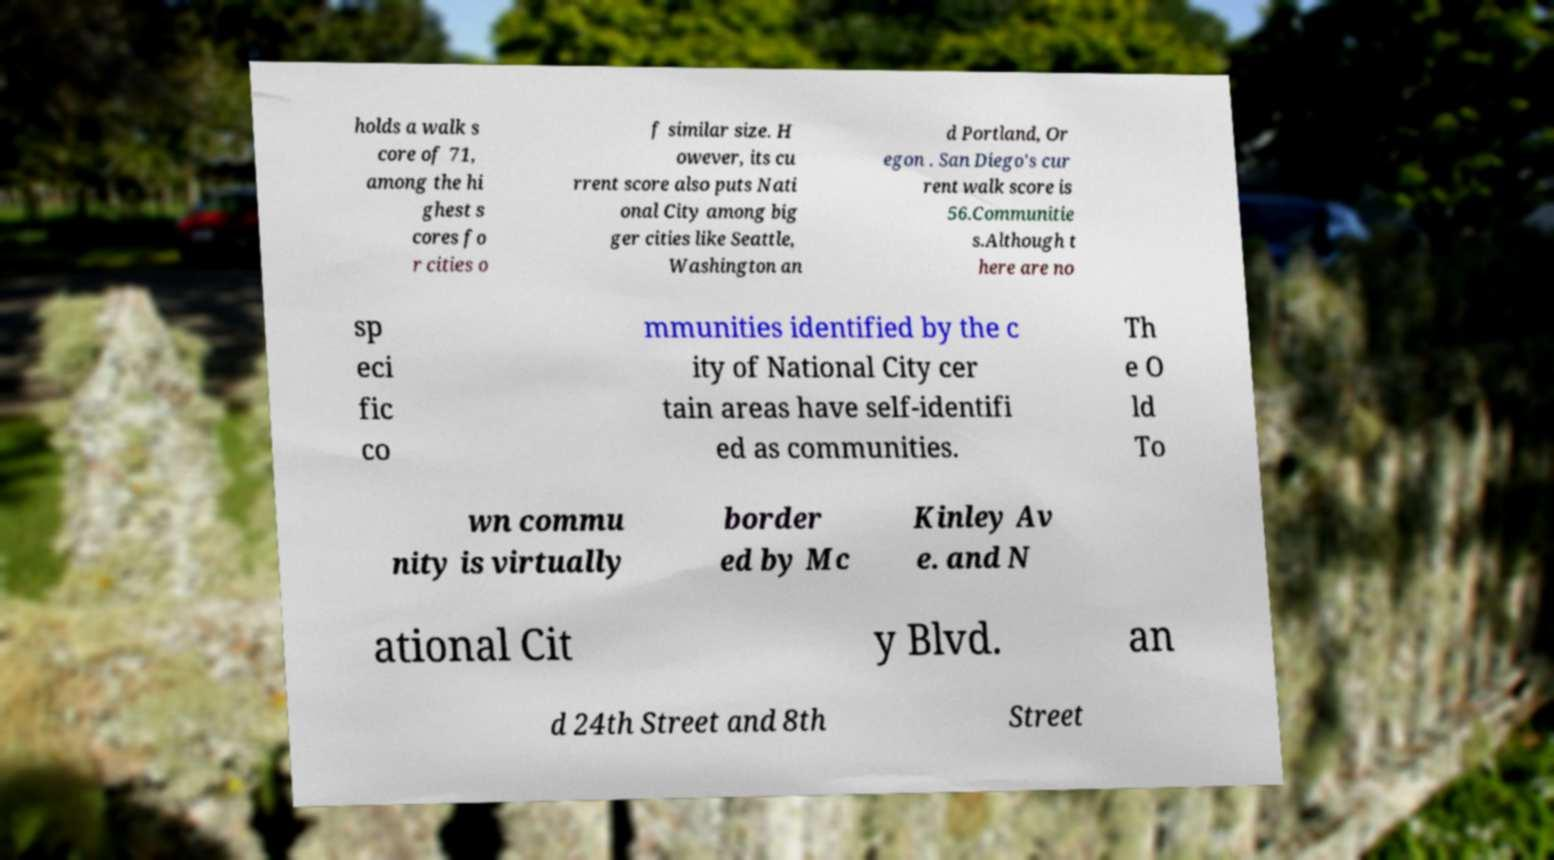Can you accurately transcribe the text from the provided image for me? holds a walk s core of 71, among the hi ghest s cores fo r cities o f similar size. H owever, its cu rrent score also puts Nati onal City among big ger cities like Seattle, Washington an d Portland, Or egon . San Diego's cur rent walk score is 56.Communitie s.Although t here are no sp eci fic co mmunities identified by the c ity of National City cer tain areas have self-identifi ed as communities. Th e O ld To wn commu nity is virtually border ed by Mc Kinley Av e. and N ational Cit y Blvd. an d 24th Street and 8th Street 